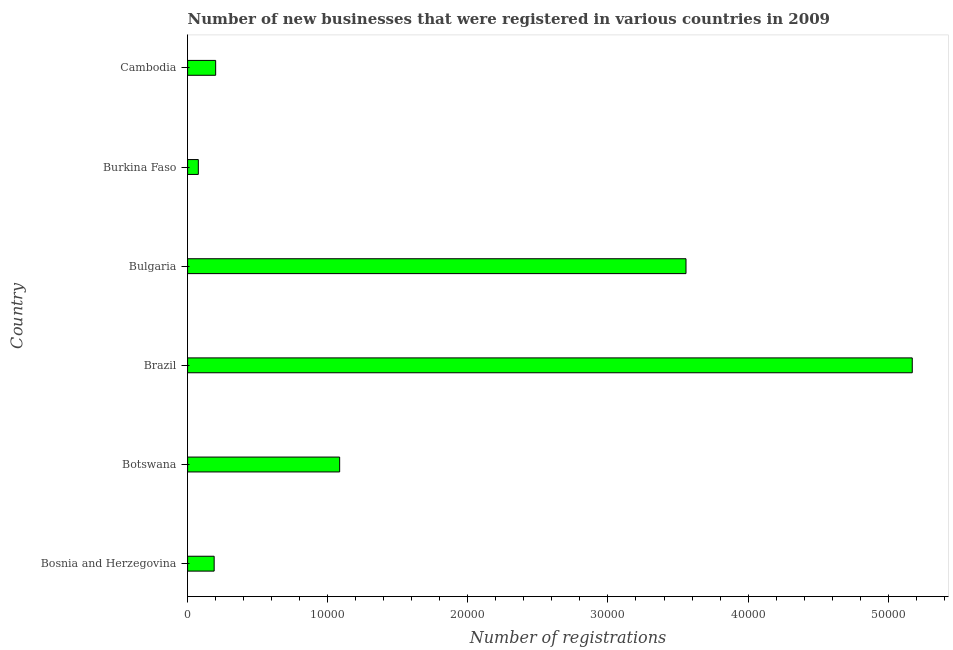Does the graph contain any zero values?
Make the answer very short. No. Does the graph contain grids?
Your answer should be very brief. No. What is the title of the graph?
Ensure brevity in your answer.  Number of new businesses that were registered in various countries in 2009. What is the label or title of the X-axis?
Your answer should be very brief. Number of registrations. What is the number of new business registrations in Burkina Faso?
Offer a very short reply. 766. Across all countries, what is the maximum number of new business registrations?
Offer a terse response. 5.17e+04. Across all countries, what is the minimum number of new business registrations?
Give a very brief answer. 766. In which country was the number of new business registrations minimum?
Your response must be concise. Burkina Faso. What is the sum of the number of new business registrations?
Provide a short and direct response. 1.03e+05. What is the difference between the number of new business registrations in Bulgaria and Burkina Faso?
Give a very brief answer. 3.48e+04. What is the average number of new business registrations per country?
Ensure brevity in your answer.  1.71e+04. What is the median number of new business registrations?
Your answer should be very brief. 6427.5. What is the ratio of the number of new business registrations in Brazil to that in Bulgaria?
Offer a terse response. 1.45. Is the number of new business registrations in Bosnia and Herzegovina less than that in Botswana?
Your answer should be compact. Yes. What is the difference between the highest and the second highest number of new business registrations?
Your answer should be compact. 1.61e+04. What is the difference between the highest and the lowest number of new business registrations?
Ensure brevity in your answer.  5.10e+04. In how many countries, is the number of new business registrations greater than the average number of new business registrations taken over all countries?
Ensure brevity in your answer.  2. How many bars are there?
Offer a terse response. 6. What is the difference between two consecutive major ticks on the X-axis?
Provide a succinct answer. 10000. What is the Number of registrations of Bosnia and Herzegovina?
Provide a short and direct response. 1896. What is the Number of registrations of Botswana?
Provide a short and direct response. 1.09e+04. What is the Number of registrations in Brazil?
Provide a short and direct response. 5.17e+04. What is the Number of registrations in Bulgaria?
Ensure brevity in your answer.  3.56e+04. What is the Number of registrations in Burkina Faso?
Your response must be concise. 766. What is the Number of registrations in Cambodia?
Your answer should be compact. 2003. What is the difference between the Number of registrations in Bosnia and Herzegovina and Botswana?
Keep it short and to the point. -8956. What is the difference between the Number of registrations in Bosnia and Herzegovina and Brazil?
Ensure brevity in your answer.  -4.98e+04. What is the difference between the Number of registrations in Bosnia and Herzegovina and Bulgaria?
Ensure brevity in your answer.  -3.37e+04. What is the difference between the Number of registrations in Bosnia and Herzegovina and Burkina Faso?
Offer a terse response. 1130. What is the difference between the Number of registrations in Bosnia and Herzegovina and Cambodia?
Your answer should be very brief. -107. What is the difference between the Number of registrations in Botswana and Brazil?
Provide a short and direct response. -4.09e+04. What is the difference between the Number of registrations in Botswana and Bulgaria?
Offer a very short reply. -2.47e+04. What is the difference between the Number of registrations in Botswana and Burkina Faso?
Give a very brief answer. 1.01e+04. What is the difference between the Number of registrations in Botswana and Cambodia?
Ensure brevity in your answer.  8849. What is the difference between the Number of registrations in Brazil and Bulgaria?
Provide a succinct answer. 1.61e+04. What is the difference between the Number of registrations in Brazil and Burkina Faso?
Your answer should be very brief. 5.10e+04. What is the difference between the Number of registrations in Brazil and Cambodia?
Provide a short and direct response. 4.97e+04. What is the difference between the Number of registrations in Bulgaria and Burkina Faso?
Offer a terse response. 3.48e+04. What is the difference between the Number of registrations in Bulgaria and Cambodia?
Offer a very short reply. 3.36e+04. What is the difference between the Number of registrations in Burkina Faso and Cambodia?
Your answer should be compact. -1237. What is the ratio of the Number of registrations in Bosnia and Herzegovina to that in Botswana?
Offer a very short reply. 0.17. What is the ratio of the Number of registrations in Bosnia and Herzegovina to that in Brazil?
Your answer should be very brief. 0.04. What is the ratio of the Number of registrations in Bosnia and Herzegovina to that in Bulgaria?
Ensure brevity in your answer.  0.05. What is the ratio of the Number of registrations in Bosnia and Herzegovina to that in Burkina Faso?
Your response must be concise. 2.48. What is the ratio of the Number of registrations in Bosnia and Herzegovina to that in Cambodia?
Make the answer very short. 0.95. What is the ratio of the Number of registrations in Botswana to that in Brazil?
Make the answer very short. 0.21. What is the ratio of the Number of registrations in Botswana to that in Bulgaria?
Your answer should be very brief. 0.3. What is the ratio of the Number of registrations in Botswana to that in Burkina Faso?
Offer a very short reply. 14.17. What is the ratio of the Number of registrations in Botswana to that in Cambodia?
Your response must be concise. 5.42. What is the ratio of the Number of registrations in Brazil to that in Bulgaria?
Offer a very short reply. 1.45. What is the ratio of the Number of registrations in Brazil to that in Burkina Faso?
Your answer should be very brief. 67.52. What is the ratio of the Number of registrations in Brazil to that in Cambodia?
Provide a succinct answer. 25.82. What is the ratio of the Number of registrations in Bulgaria to that in Burkina Faso?
Keep it short and to the point. 46.44. What is the ratio of the Number of registrations in Bulgaria to that in Cambodia?
Your answer should be very brief. 17.76. What is the ratio of the Number of registrations in Burkina Faso to that in Cambodia?
Offer a terse response. 0.38. 